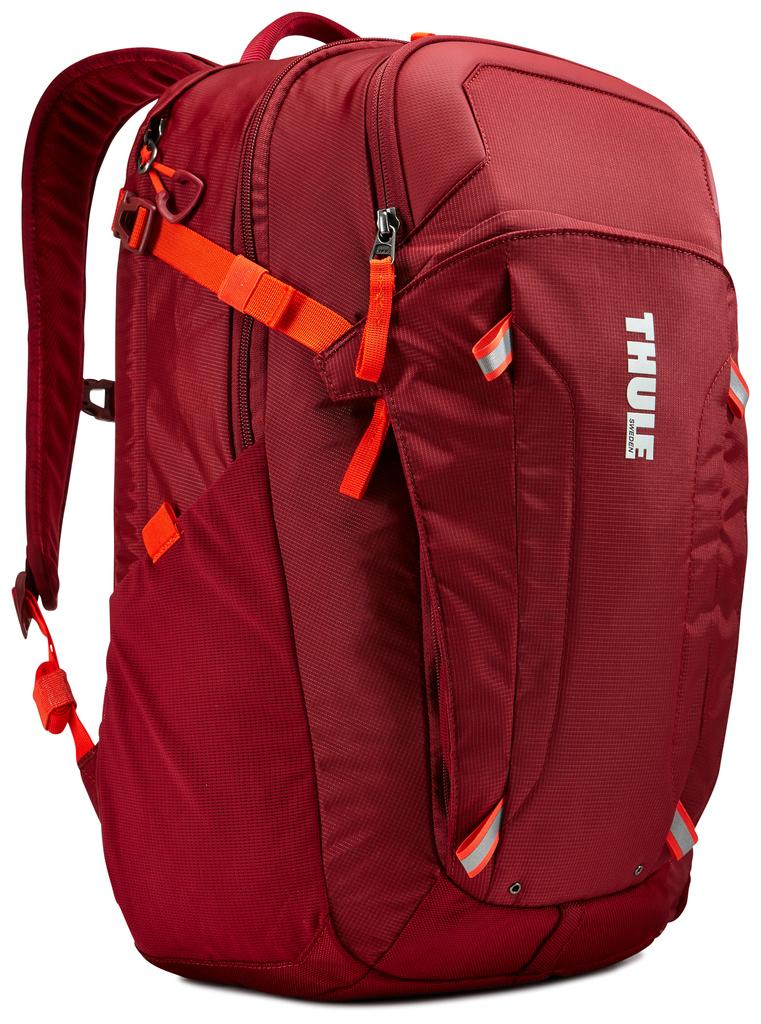<image>
Present a compact description of the photo's key features. A red THULE backpack with orange straps placed against white background. 